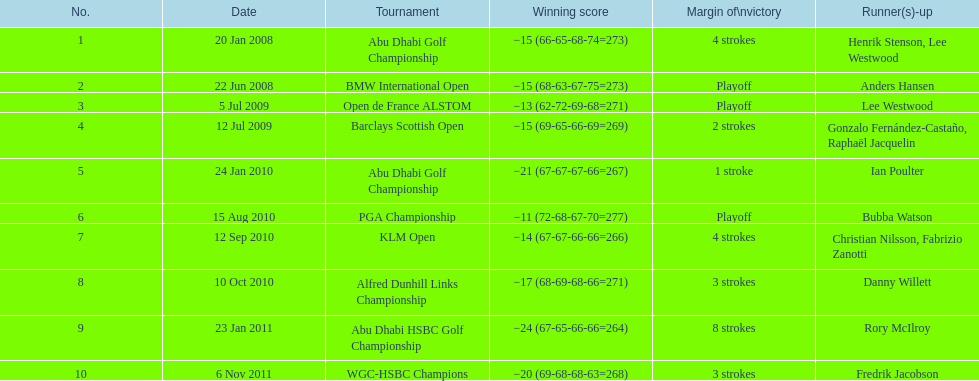How many tournaments has he won by 3 or more strokes? 5. 